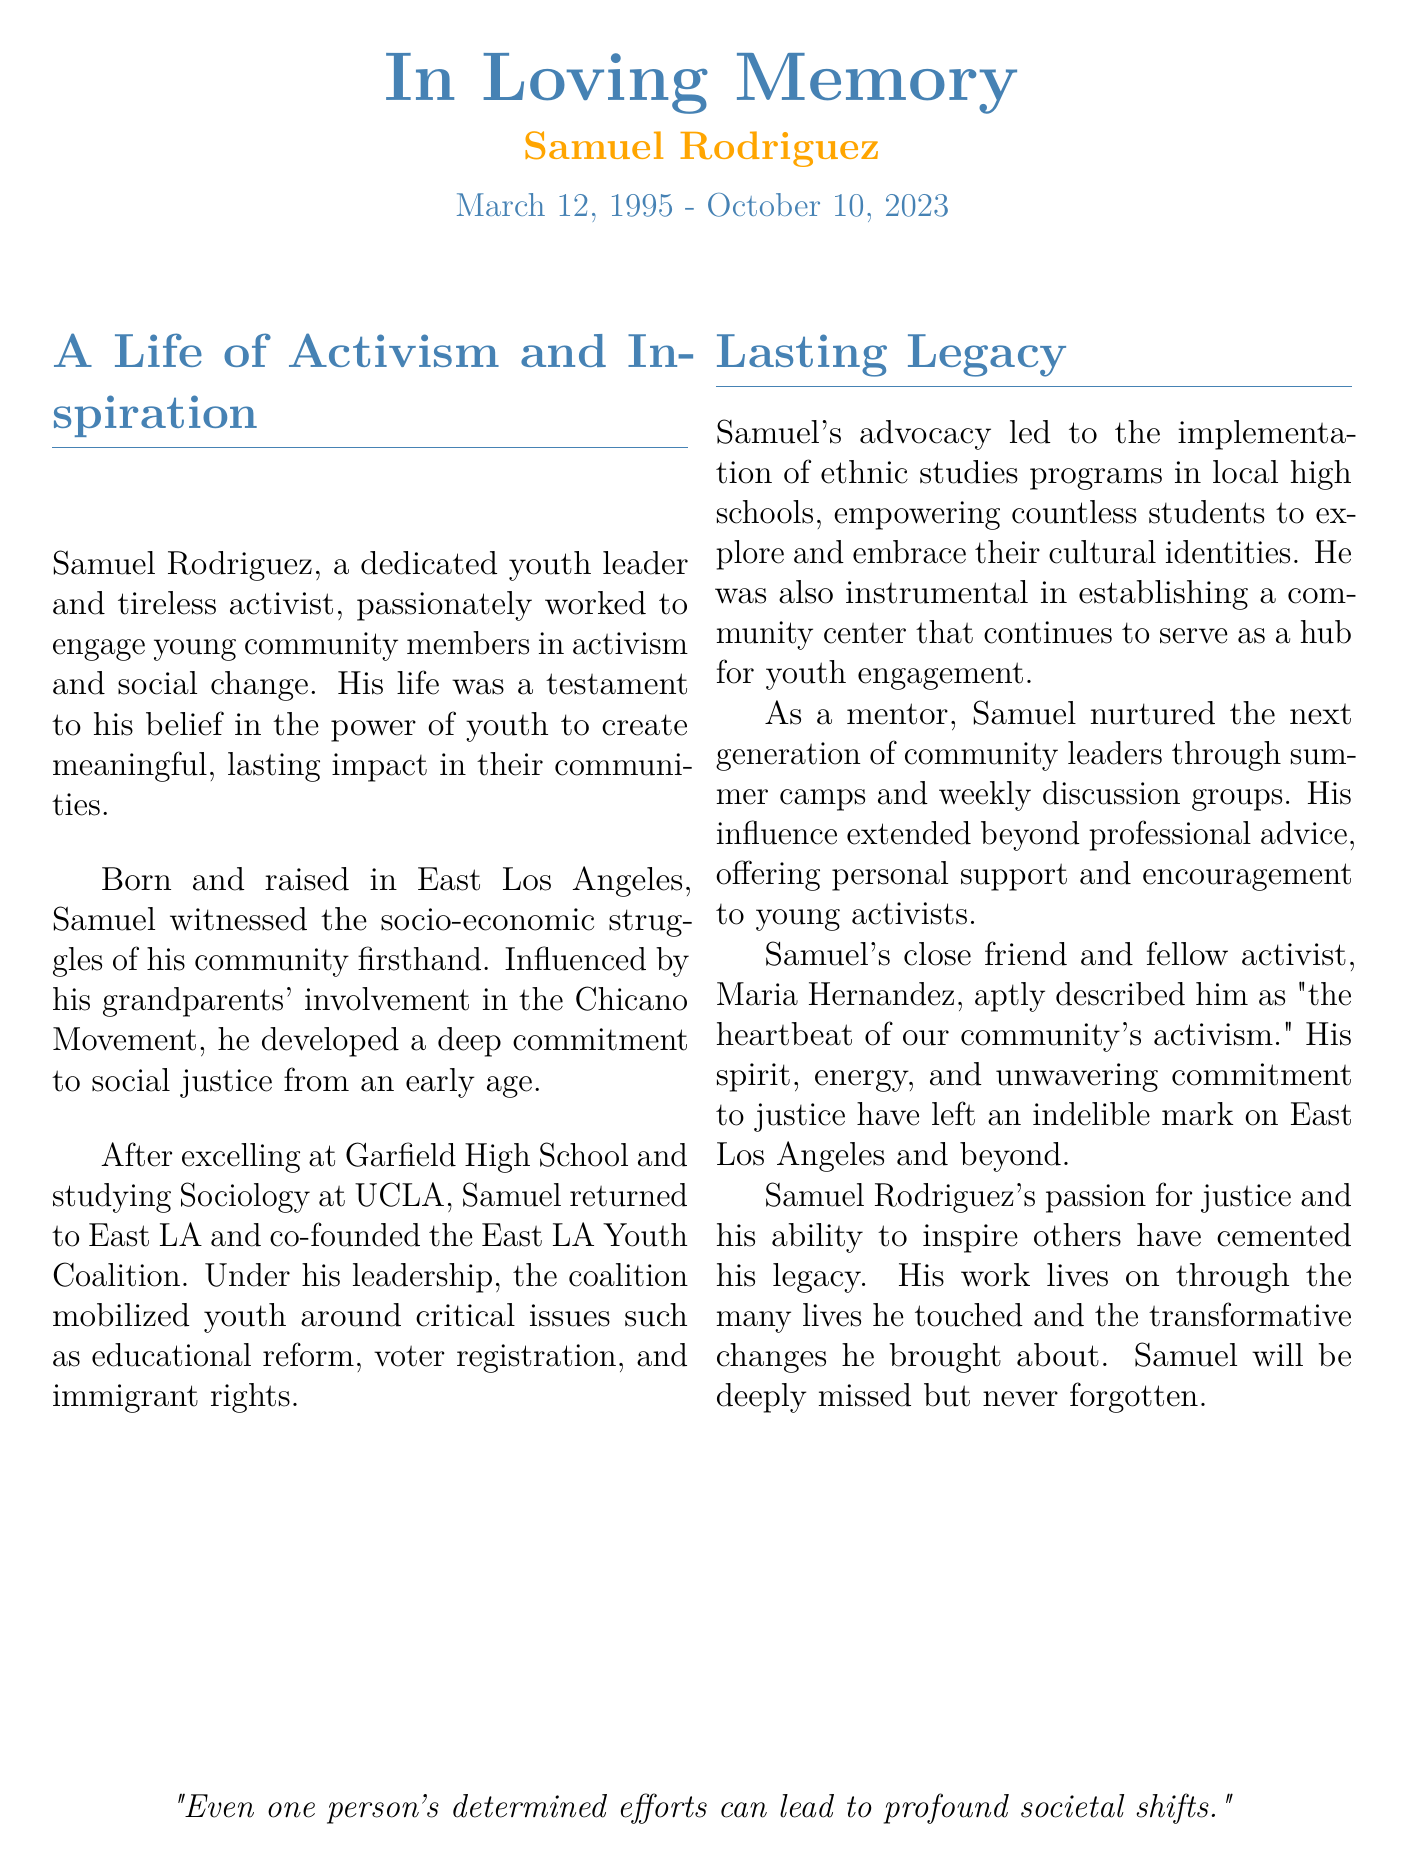What was Samuel Rodriguez's date of birth? Samuel's date of birth is stated in the document as March 12, 1995.
Answer: March 12, 1995 What university did Samuel attend? The document mentions that Samuel studied Sociology at UCLA.
Answer: UCLA What community initiative did Samuel co-found? According to the document, Samuel co-founded the East LA Youth Coalition.
Answer: East LA Youth Coalition What critical issues did the coalition mobilize youth around? The document lists educational reform, voter registration, and immigrant rights as issues.
Answer: Educational reform, voter registration, immigrant rights How did Samuel influence local high schools? The obituary states he was involved in implementing ethnic studies programs.
Answer: Ethnic studies programs Who described Samuel as "the heartbeat of our community’s activism"? The document attributes this description to Samuel's close friend, Maria Hernandez.
Answer: Maria Hernandez What programs did Samuel's mentorship include? According to the document, he nurtured young leaders through summer camps and weekly discussion groups.
Answer: Summer camps and weekly discussion groups What is the main theme of Samuel Rodriguez's legacy? The document emphasizes his passion for justice and ability to inspire others.
Answer: Passion for justice and ability to inspire When did Samuel Rodriguez pass away? The date of his passing is documented as October 10, 2023.
Answer: October 10, 2023 